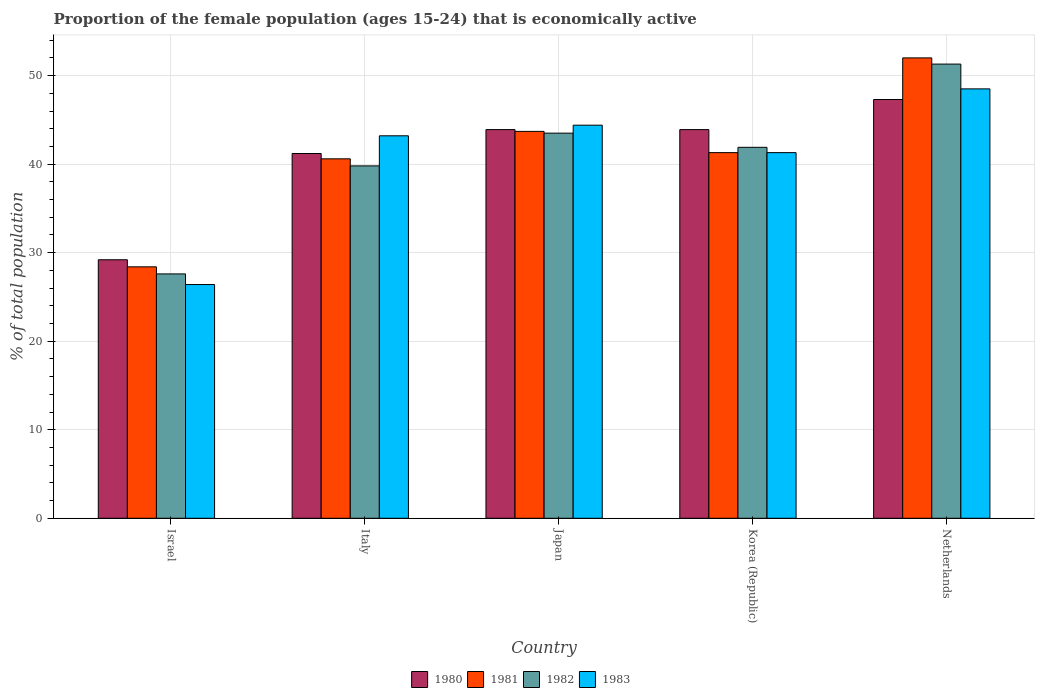How many groups of bars are there?
Your answer should be very brief. 5. Are the number of bars on each tick of the X-axis equal?
Offer a terse response. Yes. How many bars are there on the 5th tick from the left?
Give a very brief answer. 4. How many bars are there on the 4th tick from the right?
Your response must be concise. 4. In how many cases, is the number of bars for a given country not equal to the number of legend labels?
Your answer should be very brief. 0. What is the proportion of the female population that is economically active in 1983 in Korea (Republic)?
Keep it short and to the point. 41.3. Across all countries, what is the maximum proportion of the female population that is economically active in 1982?
Give a very brief answer. 51.3. Across all countries, what is the minimum proportion of the female population that is economically active in 1980?
Your response must be concise. 29.2. In which country was the proportion of the female population that is economically active in 1980 minimum?
Make the answer very short. Israel. What is the total proportion of the female population that is economically active in 1981 in the graph?
Offer a terse response. 206. What is the difference between the proportion of the female population that is economically active in 1981 in Israel and that in Japan?
Offer a very short reply. -15.3. What is the difference between the proportion of the female population that is economically active in 1980 in Korea (Republic) and the proportion of the female population that is economically active in 1982 in Italy?
Offer a terse response. 4.1. What is the average proportion of the female population that is economically active in 1982 per country?
Ensure brevity in your answer.  40.82. What is the difference between the proportion of the female population that is economically active of/in 1983 and proportion of the female population that is economically active of/in 1982 in Japan?
Make the answer very short. 0.9. What is the ratio of the proportion of the female population that is economically active in 1981 in Israel to that in Japan?
Keep it short and to the point. 0.65. Is the proportion of the female population that is economically active in 1983 in Israel less than that in Japan?
Keep it short and to the point. Yes. Is the difference between the proportion of the female population that is economically active in 1983 in Italy and Netherlands greater than the difference between the proportion of the female population that is economically active in 1982 in Italy and Netherlands?
Keep it short and to the point. Yes. What is the difference between the highest and the second highest proportion of the female population that is economically active in 1983?
Your answer should be very brief. 5.3. What is the difference between the highest and the lowest proportion of the female population that is economically active in 1982?
Provide a succinct answer. 23.7. In how many countries, is the proportion of the female population that is economically active in 1981 greater than the average proportion of the female population that is economically active in 1981 taken over all countries?
Your answer should be compact. 3. Is the sum of the proportion of the female population that is economically active in 1980 in Israel and Italy greater than the maximum proportion of the female population that is economically active in 1982 across all countries?
Offer a terse response. Yes. What does the 3rd bar from the right in Korea (Republic) represents?
Give a very brief answer. 1981. What is the difference between two consecutive major ticks on the Y-axis?
Offer a very short reply. 10. Does the graph contain any zero values?
Keep it short and to the point. No. Does the graph contain grids?
Give a very brief answer. Yes. Where does the legend appear in the graph?
Your answer should be compact. Bottom center. How many legend labels are there?
Your answer should be compact. 4. How are the legend labels stacked?
Provide a short and direct response. Horizontal. What is the title of the graph?
Offer a very short reply. Proportion of the female population (ages 15-24) that is economically active. What is the label or title of the Y-axis?
Make the answer very short. % of total population. What is the % of total population of 1980 in Israel?
Provide a succinct answer. 29.2. What is the % of total population of 1981 in Israel?
Provide a short and direct response. 28.4. What is the % of total population of 1982 in Israel?
Keep it short and to the point. 27.6. What is the % of total population in 1983 in Israel?
Give a very brief answer. 26.4. What is the % of total population in 1980 in Italy?
Give a very brief answer. 41.2. What is the % of total population of 1981 in Italy?
Offer a very short reply. 40.6. What is the % of total population of 1982 in Italy?
Provide a short and direct response. 39.8. What is the % of total population of 1983 in Italy?
Ensure brevity in your answer.  43.2. What is the % of total population in 1980 in Japan?
Make the answer very short. 43.9. What is the % of total population in 1981 in Japan?
Keep it short and to the point. 43.7. What is the % of total population of 1982 in Japan?
Offer a very short reply. 43.5. What is the % of total population of 1983 in Japan?
Offer a terse response. 44.4. What is the % of total population in 1980 in Korea (Republic)?
Ensure brevity in your answer.  43.9. What is the % of total population in 1981 in Korea (Republic)?
Your answer should be very brief. 41.3. What is the % of total population in 1982 in Korea (Republic)?
Offer a terse response. 41.9. What is the % of total population of 1983 in Korea (Republic)?
Offer a very short reply. 41.3. What is the % of total population in 1980 in Netherlands?
Keep it short and to the point. 47.3. What is the % of total population in 1982 in Netherlands?
Offer a terse response. 51.3. What is the % of total population of 1983 in Netherlands?
Provide a succinct answer. 48.5. Across all countries, what is the maximum % of total population of 1980?
Offer a very short reply. 47.3. Across all countries, what is the maximum % of total population of 1981?
Ensure brevity in your answer.  52. Across all countries, what is the maximum % of total population in 1982?
Make the answer very short. 51.3. Across all countries, what is the maximum % of total population of 1983?
Offer a terse response. 48.5. Across all countries, what is the minimum % of total population of 1980?
Keep it short and to the point. 29.2. Across all countries, what is the minimum % of total population of 1981?
Ensure brevity in your answer.  28.4. Across all countries, what is the minimum % of total population in 1982?
Offer a very short reply. 27.6. Across all countries, what is the minimum % of total population of 1983?
Ensure brevity in your answer.  26.4. What is the total % of total population in 1980 in the graph?
Ensure brevity in your answer.  205.5. What is the total % of total population of 1981 in the graph?
Your answer should be very brief. 206. What is the total % of total population of 1982 in the graph?
Offer a very short reply. 204.1. What is the total % of total population of 1983 in the graph?
Give a very brief answer. 203.8. What is the difference between the % of total population in 1980 in Israel and that in Italy?
Ensure brevity in your answer.  -12. What is the difference between the % of total population in 1982 in Israel and that in Italy?
Offer a very short reply. -12.2. What is the difference between the % of total population of 1983 in Israel and that in Italy?
Keep it short and to the point. -16.8. What is the difference between the % of total population of 1980 in Israel and that in Japan?
Keep it short and to the point. -14.7. What is the difference between the % of total population of 1981 in Israel and that in Japan?
Your response must be concise. -15.3. What is the difference between the % of total population of 1982 in Israel and that in Japan?
Your answer should be very brief. -15.9. What is the difference between the % of total population in 1983 in Israel and that in Japan?
Provide a short and direct response. -18. What is the difference between the % of total population in 1980 in Israel and that in Korea (Republic)?
Your response must be concise. -14.7. What is the difference between the % of total population in 1981 in Israel and that in Korea (Republic)?
Make the answer very short. -12.9. What is the difference between the % of total population of 1982 in Israel and that in Korea (Republic)?
Provide a succinct answer. -14.3. What is the difference between the % of total population in 1983 in Israel and that in Korea (Republic)?
Offer a terse response. -14.9. What is the difference between the % of total population of 1980 in Israel and that in Netherlands?
Provide a succinct answer. -18.1. What is the difference between the % of total population of 1981 in Israel and that in Netherlands?
Ensure brevity in your answer.  -23.6. What is the difference between the % of total population in 1982 in Israel and that in Netherlands?
Your answer should be very brief. -23.7. What is the difference between the % of total population in 1983 in Israel and that in Netherlands?
Make the answer very short. -22.1. What is the difference between the % of total population of 1980 in Italy and that in Japan?
Your response must be concise. -2.7. What is the difference between the % of total population of 1982 in Italy and that in Japan?
Provide a succinct answer. -3.7. What is the difference between the % of total population in 1980 in Italy and that in Korea (Republic)?
Your answer should be compact. -2.7. What is the difference between the % of total population in 1981 in Italy and that in Korea (Republic)?
Keep it short and to the point. -0.7. What is the difference between the % of total population in 1980 in Italy and that in Netherlands?
Offer a terse response. -6.1. What is the difference between the % of total population of 1981 in Italy and that in Netherlands?
Your response must be concise. -11.4. What is the difference between the % of total population in 1983 in Italy and that in Netherlands?
Offer a very short reply. -5.3. What is the difference between the % of total population in 1980 in Japan and that in Netherlands?
Provide a succinct answer. -3.4. What is the difference between the % of total population of 1981 in Japan and that in Netherlands?
Keep it short and to the point. -8.3. What is the difference between the % of total population in 1983 in Japan and that in Netherlands?
Make the answer very short. -4.1. What is the difference between the % of total population in 1982 in Korea (Republic) and that in Netherlands?
Keep it short and to the point. -9.4. What is the difference between the % of total population in 1983 in Korea (Republic) and that in Netherlands?
Make the answer very short. -7.2. What is the difference between the % of total population in 1980 in Israel and the % of total population in 1981 in Italy?
Provide a succinct answer. -11.4. What is the difference between the % of total population in 1980 in Israel and the % of total population in 1982 in Italy?
Your answer should be very brief. -10.6. What is the difference between the % of total population in 1980 in Israel and the % of total population in 1983 in Italy?
Offer a very short reply. -14. What is the difference between the % of total population in 1981 in Israel and the % of total population in 1983 in Italy?
Your answer should be compact. -14.8. What is the difference between the % of total population of 1982 in Israel and the % of total population of 1983 in Italy?
Your answer should be compact. -15.6. What is the difference between the % of total population of 1980 in Israel and the % of total population of 1982 in Japan?
Your answer should be compact. -14.3. What is the difference between the % of total population of 1980 in Israel and the % of total population of 1983 in Japan?
Make the answer very short. -15.2. What is the difference between the % of total population of 1981 in Israel and the % of total population of 1982 in Japan?
Offer a very short reply. -15.1. What is the difference between the % of total population of 1981 in Israel and the % of total population of 1983 in Japan?
Make the answer very short. -16. What is the difference between the % of total population of 1982 in Israel and the % of total population of 1983 in Japan?
Offer a very short reply. -16.8. What is the difference between the % of total population in 1980 in Israel and the % of total population in 1982 in Korea (Republic)?
Ensure brevity in your answer.  -12.7. What is the difference between the % of total population in 1981 in Israel and the % of total population in 1982 in Korea (Republic)?
Ensure brevity in your answer.  -13.5. What is the difference between the % of total population in 1981 in Israel and the % of total population in 1983 in Korea (Republic)?
Your answer should be very brief. -12.9. What is the difference between the % of total population of 1982 in Israel and the % of total population of 1983 in Korea (Republic)?
Provide a short and direct response. -13.7. What is the difference between the % of total population of 1980 in Israel and the % of total population of 1981 in Netherlands?
Offer a terse response. -22.8. What is the difference between the % of total population in 1980 in Israel and the % of total population in 1982 in Netherlands?
Your answer should be very brief. -22.1. What is the difference between the % of total population in 1980 in Israel and the % of total population in 1983 in Netherlands?
Ensure brevity in your answer.  -19.3. What is the difference between the % of total population of 1981 in Israel and the % of total population of 1982 in Netherlands?
Your response must be concise. -22.9. What is the difference between the % of total population of 1981 in Israel and the % of total population of 1983 in Netherlands?
Your answer should be very brief. -20.1. What is the difference between the % of total population of 1982 in Israel and the % of total population of 1983 in Netherlands?
Provide a short and direct response. -20.9. What is the difference between the % of total population in 1980 in Italy and the % of total population in 1982 in Japan?
Provide a succinct answer. -2.3. What is the difference between the % of total population in 1980 in Italy and the % of total population in 1983 in Japan?
Provide a short and direct response. -3.2. What is the difference between the % of total population in 1981 in Italy and the % of total population in 1982 in Japan?
Provide a short and direct response. -2.9. What is the difference between the % of total population in 1982 in Italy and the % of total population in 1983 in Japan?
Your answer should be compact. -4.6. What is the difference between the % of total population in 1980 in Italy and the % of total population in 1981 in Netherlands?
Your response must be concise. -10.8. What is the difference between the % of total population of 1981 in Italy and the % of total population of 1982 in Netherlands?
Make the answer very short. -10.7. What is the difference between the % of total population of 1981 in Italy and the % of total population of 1983 in Netherlands?
Your response must be concise. -7.9. What is the difference between the % of total population in 1980 in Japan and the % of total population in 1983 in Korea (Republic)?
Ensure brevity in your answer.  2.6. What is the difference between the % of total population of 1981 in Japan and the % of total population of 1982 in Korea (Republic)?
Your answer should be compact. 1.8. What is the difference between the % of total population of 1982 in Japan and the % of total population of 1983 in Korea (Republic)?
Provide a succinct answer. 2.2. What is the difference between the % of total population in 1980 in Japan and the % of total population in 1981 in Netherlands?
Offer a very short reply. -8.1. What is the difference between the % of total population of 1981 in Japan and the % of total population of 1983 in Netherlands?
Make the answer very short. -4.8. What is the difference between the % of total population of 1982 in Japan and the % of total population of 1983 in Netherlands?
Offer a terse response. -5. What is the difference between the % of total population of 1980 in Korea (Republic) and the % of total population of 1981 in Netherlands?
Provide a succinct answer. -8.1. What is the difference between the % of total population in 1980 in Korea (Republic) and the % of total population in 1982 in Netherlands?
Provide a succinct answer. -7.4. What is the difference between the % of total population in 1981 in Korea (Republic) and the % of total population in 1982 in Netherlands?
Your answer should be compact. -10. What is the difference between the % of total population in 1981 in Korea (Republic) and the % of total population in 1983 in Netherlands?
Your answer should be very brief. -7.2. What is the average % of total population of 1980 per country?
Provide a short and direct response. 41.1. What is the average % of total population in 1981 per country?
Your answer should be compact. 41.2. What is the average % of total population of 1982 per country?
Make the answer very short. 40.82. What is the average % of total population of 1983 per country?
Keep it short and to the point. 40.76. What is the difference between the % of total population in 1980 and % of total population in 1981 in Israel?
Make the answer very short. 0.8. What is the difference between the % of total population of 1980 and % of total population of 1981 in Italy?
Offer a very short reply. 0.6. What is the difference between the % of total population of 1980 and % of total population of 1983 in Italy?
Provide a succinct answer. -2. What is the difference between the % of total population in 1981 and % of total population in 1982 in Italy?
Give a very brief answer. 0.8. What is the difference between the % of total population of 1981 and % of total population of 1983 in Italy?
Keep it short and to the point. -2.6. What is the difference between the % of total population in 1980 and % of total population in 1981 in Japan?
Your answer should be compact. 0.2. What is the difference between the % of total population of 1980 and % of total population of 1983 in Japan?
Your answer should be very brief. -0.5. What is the difference between the % of total population of 1981 and % of total population of 1983 in Japan?
Give a very brief answer. -0.7. What is the difference between the % of total population of 1982 and % of total population of 1983 in Japan?
Provide a succinct answer. -0.9. What is the difference between the % of total population in 1982 and % of total population in 1983 in Korea (Republic)?
Provide a succinct answer. 0.6. What is the difference between the % of total population in 1980 and % of total population in 1981 in Netherlands?
Offer a very short reply. -4.7. What is the difference between the % of total population of 1980 and % of total population of 1983 in Netherlands?
Make the answer very short. -1.2. What is the difference between the % of total population of 1981 and % of total population of 1982 in Netherlands?
Keep it short and to the point. 0.7. What is the difference between the % of total population in 1982 and % of total population in 1983 in Netherlands?
Keep it short and to the point. 2.8. What is the ratio of the % of total population in 1980 in Israel to that in Italy?
Your answer should be compact. 0.71. What is the ratio of the % of total population in 1981 in Israel to that in Italy?
Provide a short and direct response. 0.7. What is the ratio of the % of total population in 1982 in Israel to that in Italy?
Provide a short and direct response. 0.69. What is the ratio of the % of total population in 1983 in Israel to that in Italy?
Your answer should be compact. 0.61. What is the ratio of the % of total population in 1980 in Israel to that in Japan?
Your answer should be very brief. 0.67. What is the ratio of the % of total population of 1981 in Israel to that in Japan?
Make the answer very short. 0.65. What is the ratio of the % of total population in 1982 in Israel to that in Japan?
Offer a terse response. 0.63. What is the ratio of the % of total population in 1983 in Israel to that in Japan?
Ensure brevity in your answer.  0.59. What is the ratio of the % of total population in 1980 in Israel to that in Korea (Republic)?
Offer a very short reply. 0.67. What is the ratio of the % of total population in 1981 in Israel to that in Korea (Republic)?
Your answer should be very brief. 0.69. What is the ratio of the % of total population in 1982 in Israel to that in Korea (Republic)?
Provide a short and direct response. 0.66. What is the ratio of the % of total population of 1983 in Israel to that in Korea (Republic)?
Your answer should be compact. 0.64. What is the ratio of the % of total population in 1980 in Israel to that in Netherlands?
Make the answer very short. 0.62. What is the ratio of the % of total population of 1981 in Israel to that in Netherlands?
Your answer should be very brief. 0.55. What is the ratio of the % of total population of 1982 in Israel to that in Netherlands?
Offer a terse response. 0.54. What is the ratio of the % of total population of 1983 in Israel to that in Netherlands?
Your answer should be very brief. 0.54. What is the ratio of the % of total population in 1980 in Italy to that in Japan?
Your answer should be compact. 0.94. What is the ratio of the % of total population of 1981 in Italy to that in Japan?
Your answer should be very brief. 0.93. What is the ratio of the % of total population of 1982 in Italy to that in Japan?
Give a very brief answer. 0.91. What is the ratio of the % of total population in 1983 in Italy to that in Japan?
Your answer should be compact. 0.97. What is the ratio of the % of total population in 1980 in Italy to that in Korea (Republic)?
Offer a terse response. 0.94. What is the ratio of the % of total population in 1981 in Italy to that in Korea (Republic)?
Ensure brevity in your answer.  0.98. What is the ratio of the % of total population in 1982 in Italy to that in Korea (Republic)?
Your answer should be very brief. 0.95. What is the ratio of the % of total population of 1983 in Italy to that in Korea (Republic)?
Your answer should be compact. 1.05. What is the ratio of the % of total population in 1980 in Italy to that in Netherlands?
Provide a short and direct response. 0.87. What is the ratio of the % of total population in 1981 in Italy to that in Netherlands?
Provide a short and direct response. 0.78. What is the ratio of the % of total population of 1982 in Italy to that in Netherlands?
Your response must be concise. 0.78. What is the ratio of the % of total population in 1983 in Italy to that in Netherlands?
Your response must be concise. 0.89. What is the ratio of the % of total population in 1980 in Japan to that in Korea (Republic)?
Offer a terse response. 1. What is the ratio of the % of total population of 1981 in Japan to that in Korea (Republic)?
Provide a succinct answer. 1.06. What is the ratio of the % of total population in 1982 in Japan to that in Korea (Republic)?
Give a very brief answer. 1.04. What is the ratio of the % of total population of 1983 in Japan to that in Korea (Republic)?
Offer a terse response. 1.08. What is the ratio of the % of total population in 1980 in Japan to that in Netherlands?
Make the answer very short. 0.93. What is the ratio of the % of total population of 1981 in Japan to that in Netherlands?
Your answer should be compact. 0.84. What is the ratio of the % of total population in 1982 in Japan to that in Netherlands?
Provide a succinct answer. 0.85. What is the ratio of the % of total population of 1983 in Japan to that in Netherlands?
Make the answer very short. 0.92. What is the ratio of the % of total population of 1980 in Korea (Republic) to that in Netherlands?
Make the answer very short. 0.93. What is the ratio of the % of total population in 1981 in Korea (Republic) to that in Netherlands?
Offer a terse response. 0.79. What is the ratio of the % of total population in 1982 in Korea (Republic) to that in Netherlands?
Provide a short and direct response. 0.82. What is the ratio of the % of total population of 1983 in Korea (Republic) to that in Netherlands?
Your answer should be compact. 0.85. What is the difference between the highest and the second highest % of total population of 1981?
Give a very brief answer. 8.3. What is the difference between the highest and the second highest % of total population of 1982?
Provide a short and direct response. 7.8. What is the difference between the highest and the lowest % of total population of 1981?
Your response must be concise. 23.6. What is the difference between the highest and the lowest % of total population in 1982?
Your answer should be very brief. 23.7. What is the difference between the highest and the lowest % of total population in 1983?
Provide a succinct answer. 22.1. 